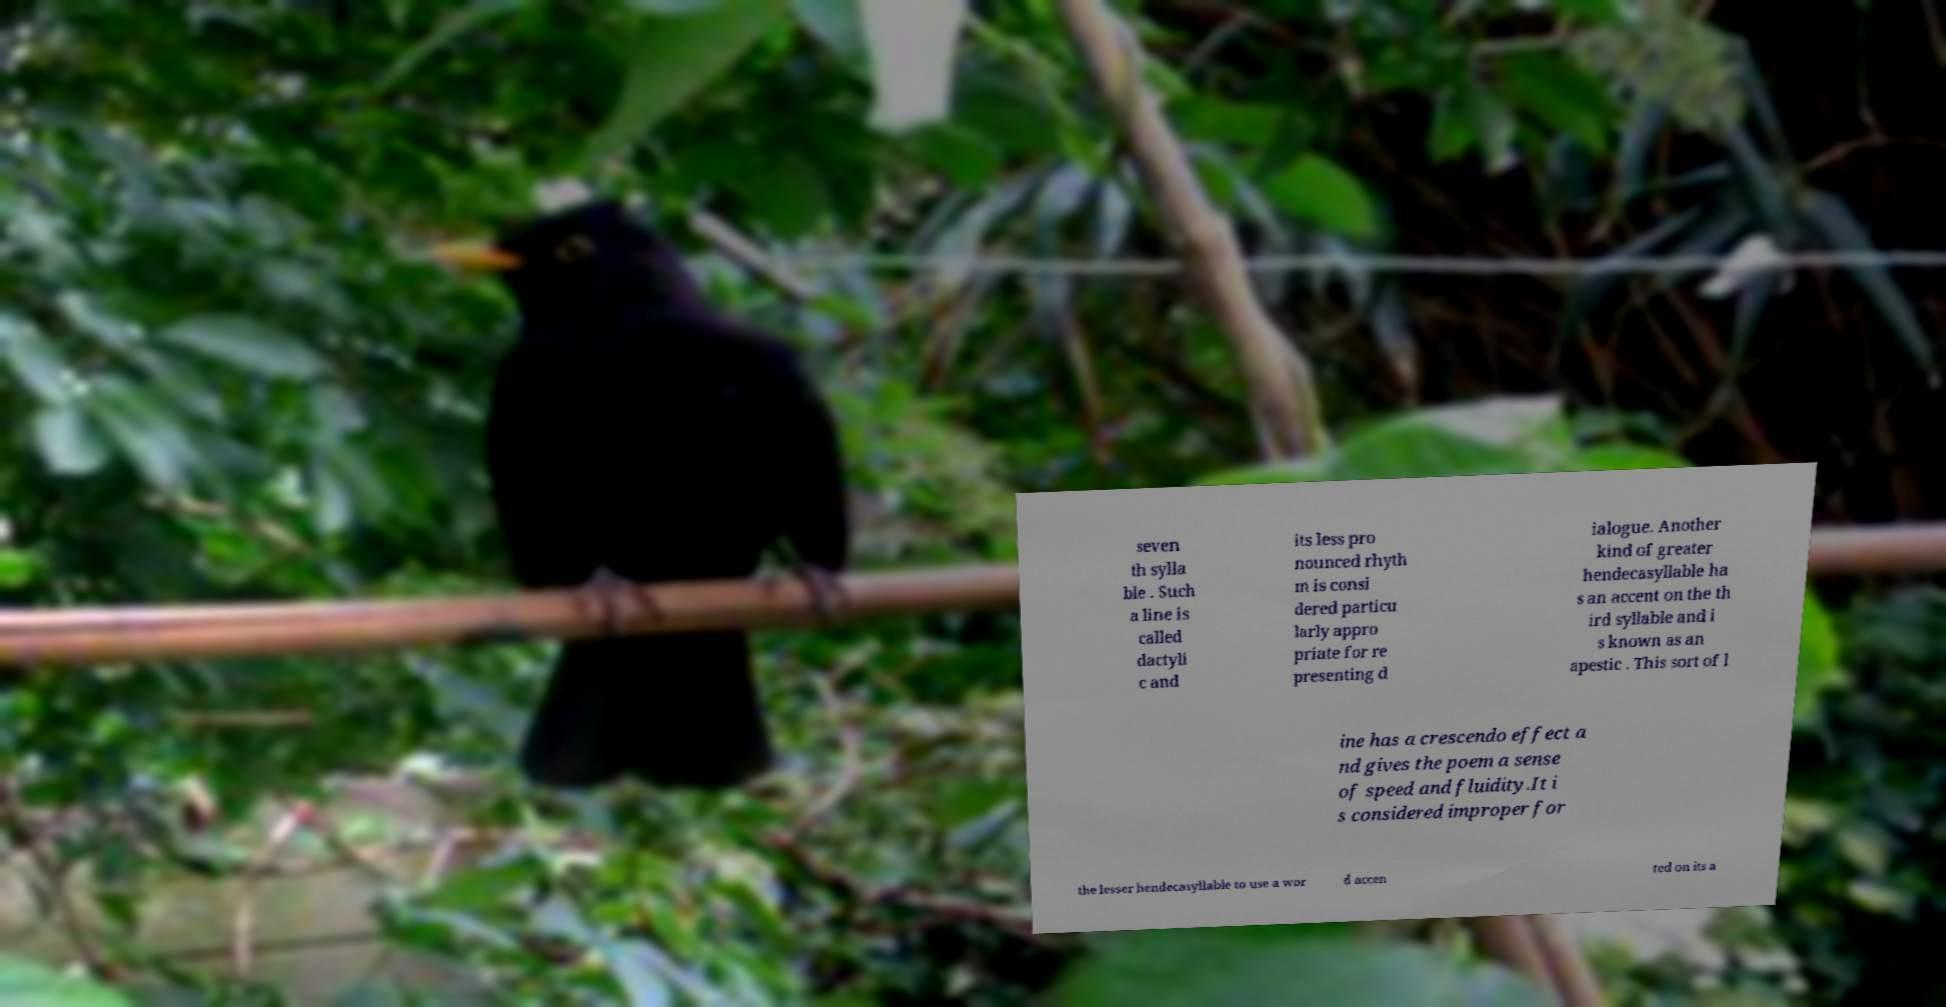Can you read and provide the text displayed in the image?This photo seems to have some interesting text. Can you extract and type it out for me? seven th sylla ble . Such a line is called dactyli c and its less pro nounced rhyth m is consi dered particu larly appro priate for re presenting d ialogue. Another kind of greater hendecasyllable ha s an accent on the th ird syllable and i s known as an apestic . This sort of l ine has a crescendo effect a nd gives the poem a sense of speed and fluidity.It i s considered improper for the lesser hendecasyllable to use a wor d accen ted on its a 